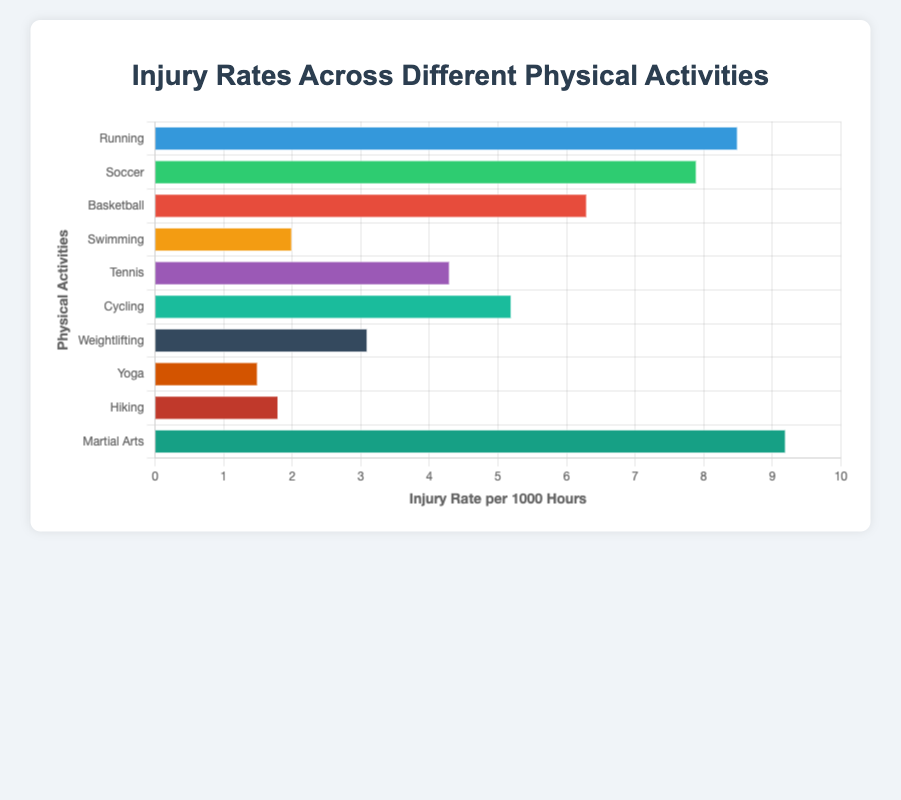Which physical activity has the highest injury rate per 1000 hours? The bar representing "Martial Arts" is the longest, indicating the highest injury rate per 1000 hours.
Answer: Martial Arts What is the difference in injury rates between Running and Swimming? The injury rate for Running is 8.5, and for Swimming it is 2.0. The difference is 8.5 - 2.0 = 6.5.
Answer: 6.5 Which activity has a lower injury rate, Tennis or Cycling? By comparing the lengths of the bars, Cycling has a lower injury rate at 5.2 compared to Tennis at 4.3.
Answer: Tennis What is the average injury rate per 1000 hours across all activities? Add all injury rates (8.5 + 7.9 + 6.3 + 2.0 + 4.3 + 5.2 + 3.1 + 1.5 + 1.8 + 9.2) = 49.8, then divide by the number of activities (10). 49.8 / 10 = 4.98.
Answer: 4.98 How many activities have an injury rate higher than 5 per 1000 hours? Activities with injury rates higher than 5 are Running (8.5), Soccer (7.9), Basketball (6.3), Martial Arts (9.2), and Cycling (5.2). That totals to 5 activities.
Answer: 5 Is the injury rate of Weightlifting greater than Yoga and Hiking combined? Weightlifting has an injury rate of 3.1. Yoga and Hiking combined have 1.5 + 1.8 = 3.3. Since 3.1 < 3.3, Weightlifting’s rate is not greater.
Answer: No What is the median injury rate of all activities? Arrange the rates in ascending order: 1.5, 1.8, 2.0, 3.1, 4.3, 5.2, 6.3, 7.9, 8.5, 9.2. The middle values are 4.3 and 5.2, so the median is (4.3 + 5.2) / 2 = 4.75.
Answer: 4.75 Which activity has the lowest injury rate, and how does it compare to the activity with the highest rate? Yoga has the lowest injury rate at 1.5, and Martial Arts has the highest at 9.2. The difference is 9.2 - 1.5 = 7.7.
Answer: Yoga, 7.7 What is the total injury rate for the activities with rates under 3? Adding the injury rates for Yoga (1.5), Hiking (1.8), and Swimming (2.0) results in 1.5 + 1.8 + 2.0 = 5.3.
Answer: 5.3 